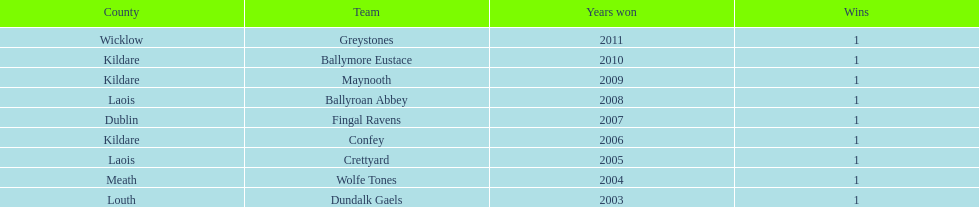What is the total of wins on the chart 9. 